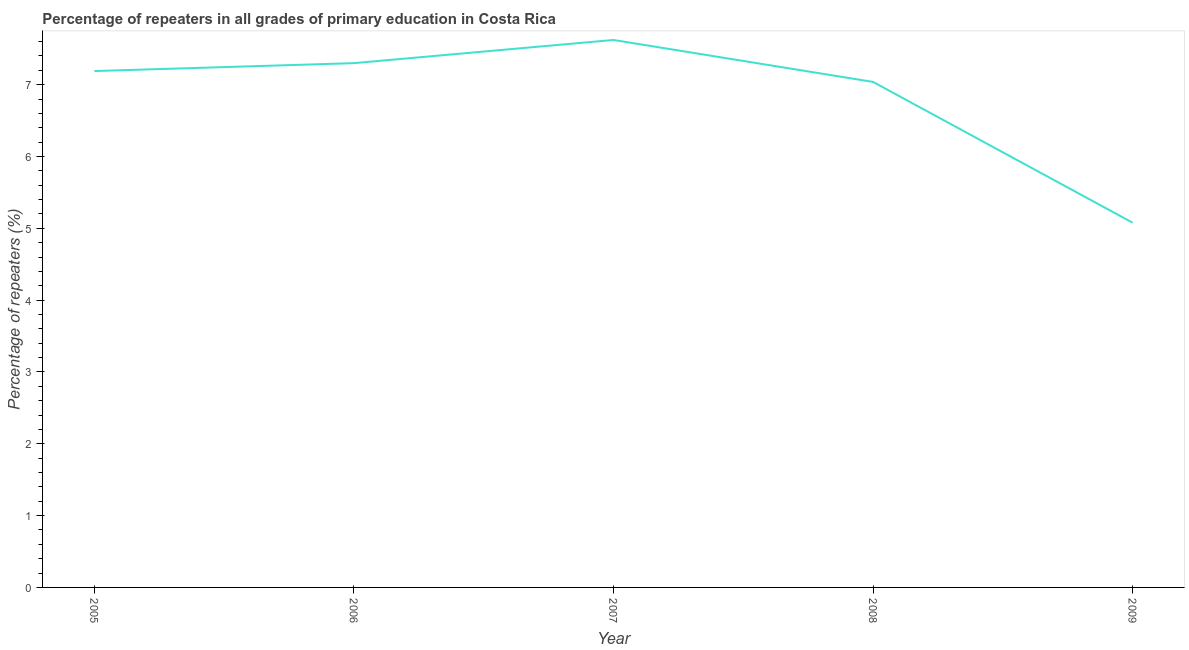What is the percentage of repeaters in primary education in 2008?
Give a very brief answer. 7.04. Across all years, what is the maximum percentage of repeaters in primary education?
Your response must be concise. 7.62. Across all years, what is the minimum percentage of repeaters in primary education?
Keep it short and to the point. 5.08. In which year was the percentage of repeaters in primary education minimum?
Provide a short and direct response. 2009. What is the sum of the percentage of repeaters in primary education?
Offer a terse response. 34.23. What is the difference between the percentage of repeaters in primary education in 2007 and 2009?
Your response must be concise. 2.54. What is the average percentage of repeaters in primary education per year?
Make the answer very short. 6.85. What is the median percentage of repeaters in primary education?
Ensure brevity in your answer.  7.19. In how many years, is the percentage of repeaters in primary education greater than 6.2 %?
Offer a terse response. 4. Do a majority of the years between 2006 and 2007 (inclusive) have percentage of repeaters in primary education greater than 5.2 %?
Ensure brevity in your answer.  Yes. What is the ratio of the percentage of repeaters in primary education in 2008 to that in 2009?
Give a very brief answer. 1.39. Is the percentage of repeaters in primary education in 2006 less than that in 2009?
Give a very brief answer. No. What is the difference between the highest and the second highest percentage of repeaters in primary education?
Keep it short and to the point. 0.32. Is the sum of the percentage of repeaters in primary education in 2005 and 2006 greater than the maximum percentage of repeaters in primary education across all years?
Your response must be concise. Yes. What is the difference between the highest and the lowest percentage of repeaters in primary education?
Give a very brief answer. 2.54. Does the percentage of repeaters in primary education monotonically increase over the years?
Keep it short and to the point. No. How many lines are there?
Ensure brevity in your answer.  1. How many years are there in the graph?
Your answer should be compact. 5. What is the difference between two consecutive major ticks on the Y-axis?
Keep it short and to the point. 1. Does the graph contain any zero values?
Keep it short and to the point. No. Does the graph contain grids?
Your answer should be compact. No. What is the title of the graph?
Make the answer very short. Percentage of repeaters in all grades of primary education in Costa Rica. What is the label or title of the X-axis?
Make the answer very short. Year. What is the label or title of the Y-axis?
Keep it short and to the point. Percentage of repeaters (%). What is the Percentage of repeaters (%) of 2005?
Give a very brief answer. 7.19. What is the Percentage of repeaters (%) of 2006?
Give a very brief answer. 7.3. What is the Percentage of repeaters (%) in 2007?
Offer a very short reply. 7.62. What is the Percentage of repeaters (%) in 2008?
Provide a short and direct response. 7.04. What is the Percentage of repeaters (%) of 2009?
Offer a terse response. 5.08. What is the difference between the Percentage of repeaters (%) in 2005 and 2006?
Keep it short and to the point. -0.11. What is the difference between the Percentage of repeaters (%) in 2005 and 2007?
Your answer should be very brief. -0.43. What is the difference between the Percentage of repeaters (%) in 2005 and 2008?
Provide a short and direct response. 0.15. What is the difference between the Percentage of repeaters (%) in 2005 and 2009?
Give a very brief answer. 2.11. What is the difference between the Percentage of repeaters (%) in 2006 and 2007?
Provide a short and direct response. -0.32. What is the difference between the Percentage of repeaters (%) in 2006 and 2008?
Provide a succinct answer. 0.26. What is the difference between the Percentage of repeaters (%) in 2006 and 2009?
Offer a very short reply. 2.22. What is the difference between the Percentage of repeaters (%) in 2007 and 2008?
Make the answer very short. 0.58. What is the difference between the Percentage of repeaters (%) in 2007 and 2009?
Provide a short and direct response. 2.54. What is the difference between the Percentage of repeaters (%) in 2008 and 2009?
Provide a short and direct response. 1.96. What is the ratio of the Percentage of repeaters (%) in 2005 to that in 2006?
Offer a terse response. 0.98. What is the ratio of the Percentage of repeaters (%) in 2005 to that in 2007?
Give a very brief answer. 0.94. What is the ratio of the Percentage of repeaters (%) in 2005 to that in 2008?
Offer a terse response. 1.02. What is the ratio of the Percentage of repeaters (%) in 2005 to that in 2009?
Provide a short and direct response. 1.42. What is the ratio of the Percentage of repeaters (%) in 2006 to that in 2007?
Offer a terse response. 0.96. What is the ratio of the Percentage of repeaters (%) in 2006 to that in 2008?
Give a very brief answer. 1.04. What is the ratio of the Percentage of repeaters (%) in 2006 to that in 2009?
Make the answer very short. 1.44. What is the ratio of the Percentage of repeaters (%) in 2007 to that in 2008?
Ensure brevity in your answer.  1.08. What is the ratio of the Percentage of repeaters (%) in 2007 to that in 2009?
Offer a terse response. 1.5. What is the ratio of the Percentage of repeaters (%) in 2008 to that in 2009?
Make the answer very short. 1.39. 